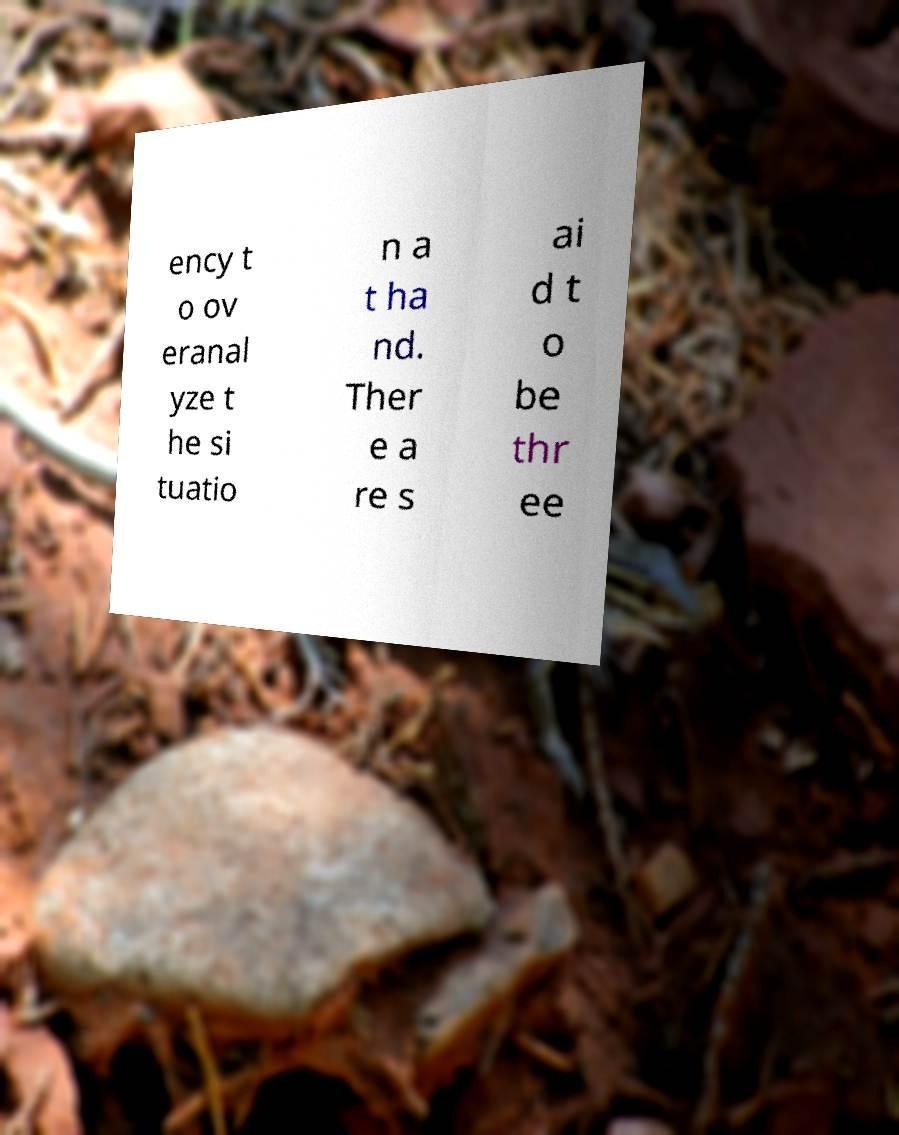Could you extract and type out the text from this image? ency t o ov eranal yze t he si tuatio n a t ha nd. Ther e a re s ai d t o be thr ee 